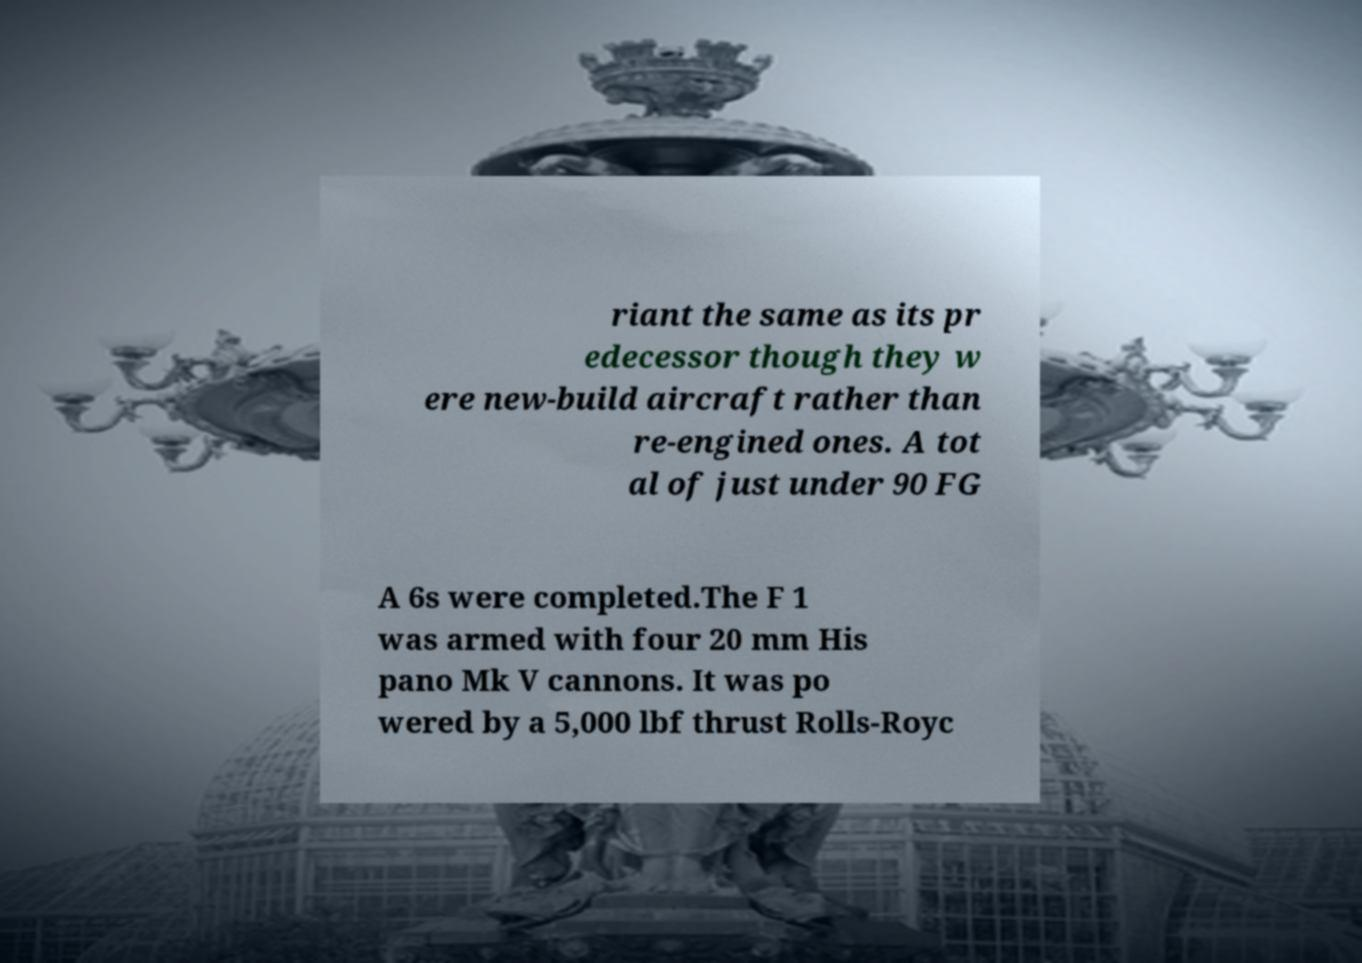Please identify and transcribe the text found in this image. riant the same as its pr edecessor though they w ere new-build aircraft rather than re-engined ones. A tot al of just under 90 FG A 6s were completed.The F 1 was armed with four 20 mm His pano Mk V cannons. It was po wered by a 5,000 lbf thrust Rolls-Royc 